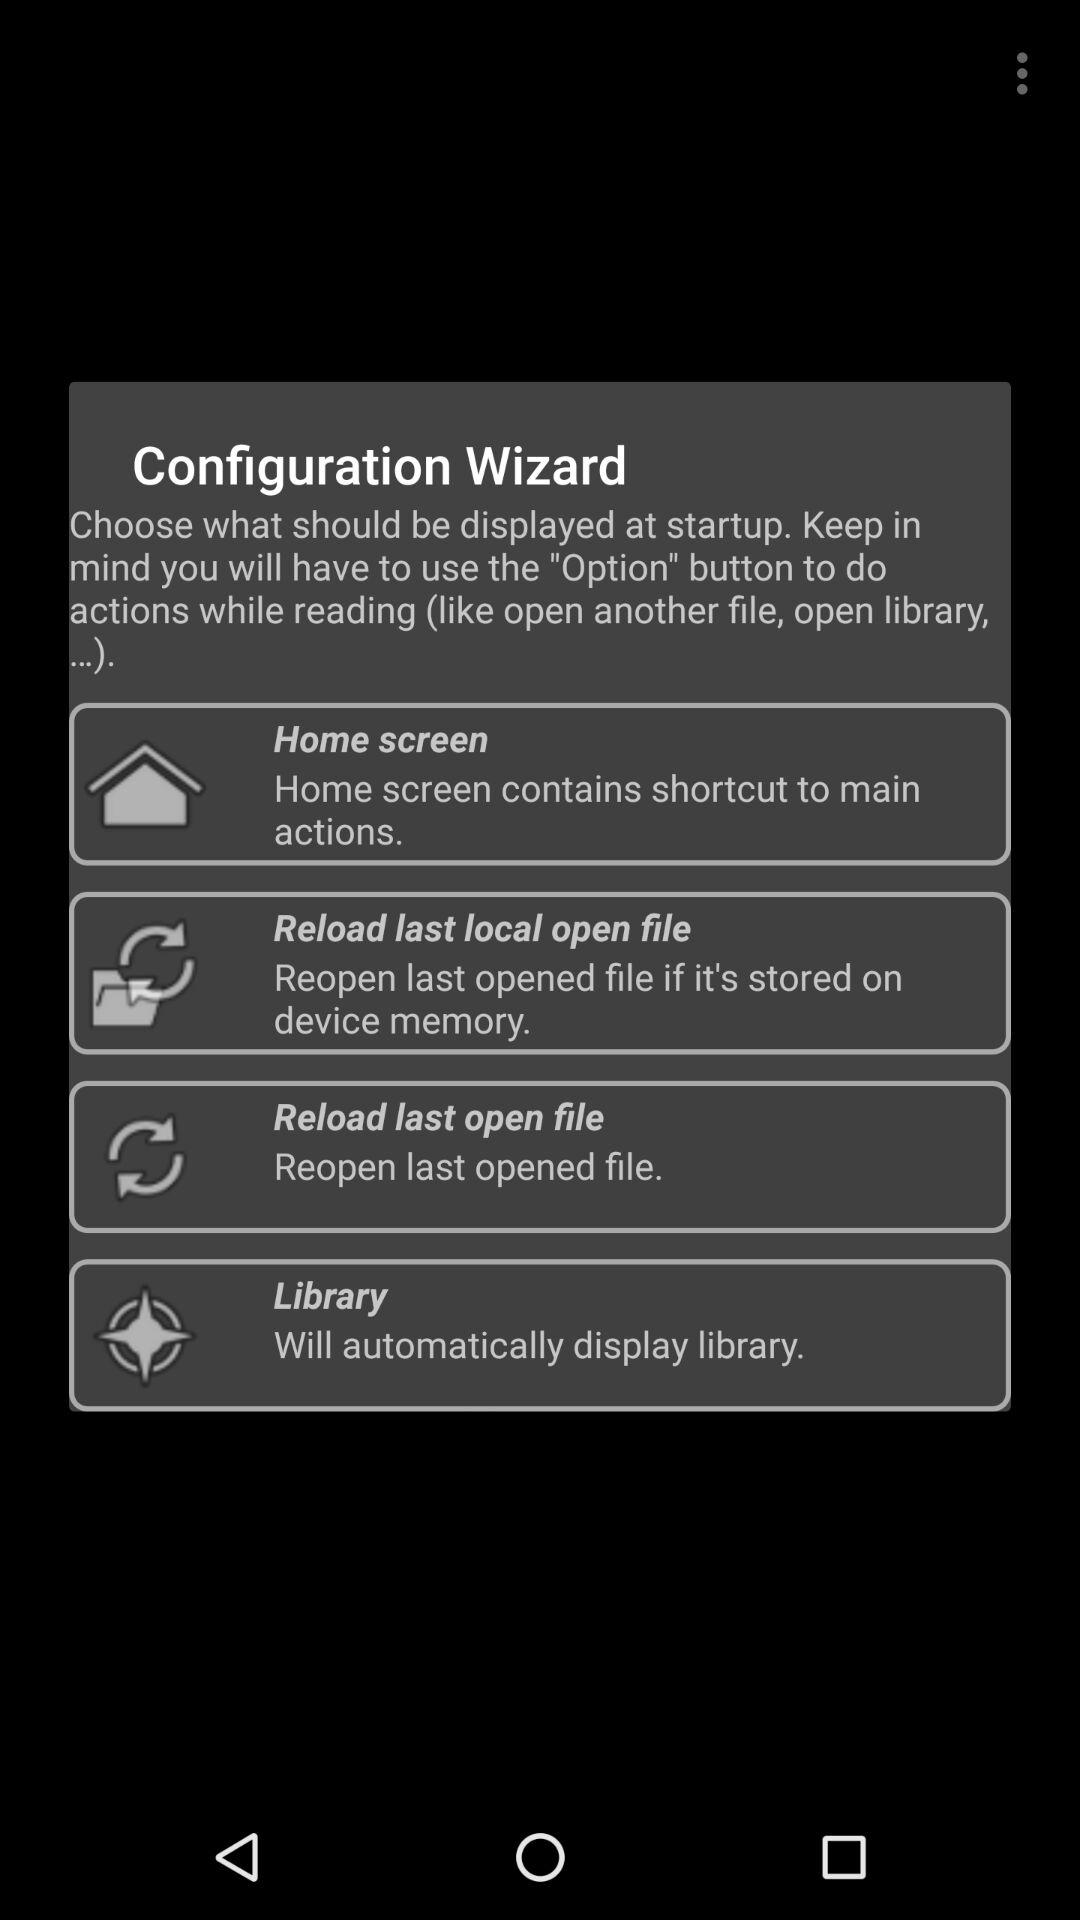How many options are there in the "Configuration Wizard"?
Answer the question using a single word or phrase. 4 